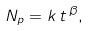Convert formula to latex. <formula><loc_0><loc_0><loc_500><loc_500>N _ { p } = k \, t \, ^ { \beta } ,</formula> 